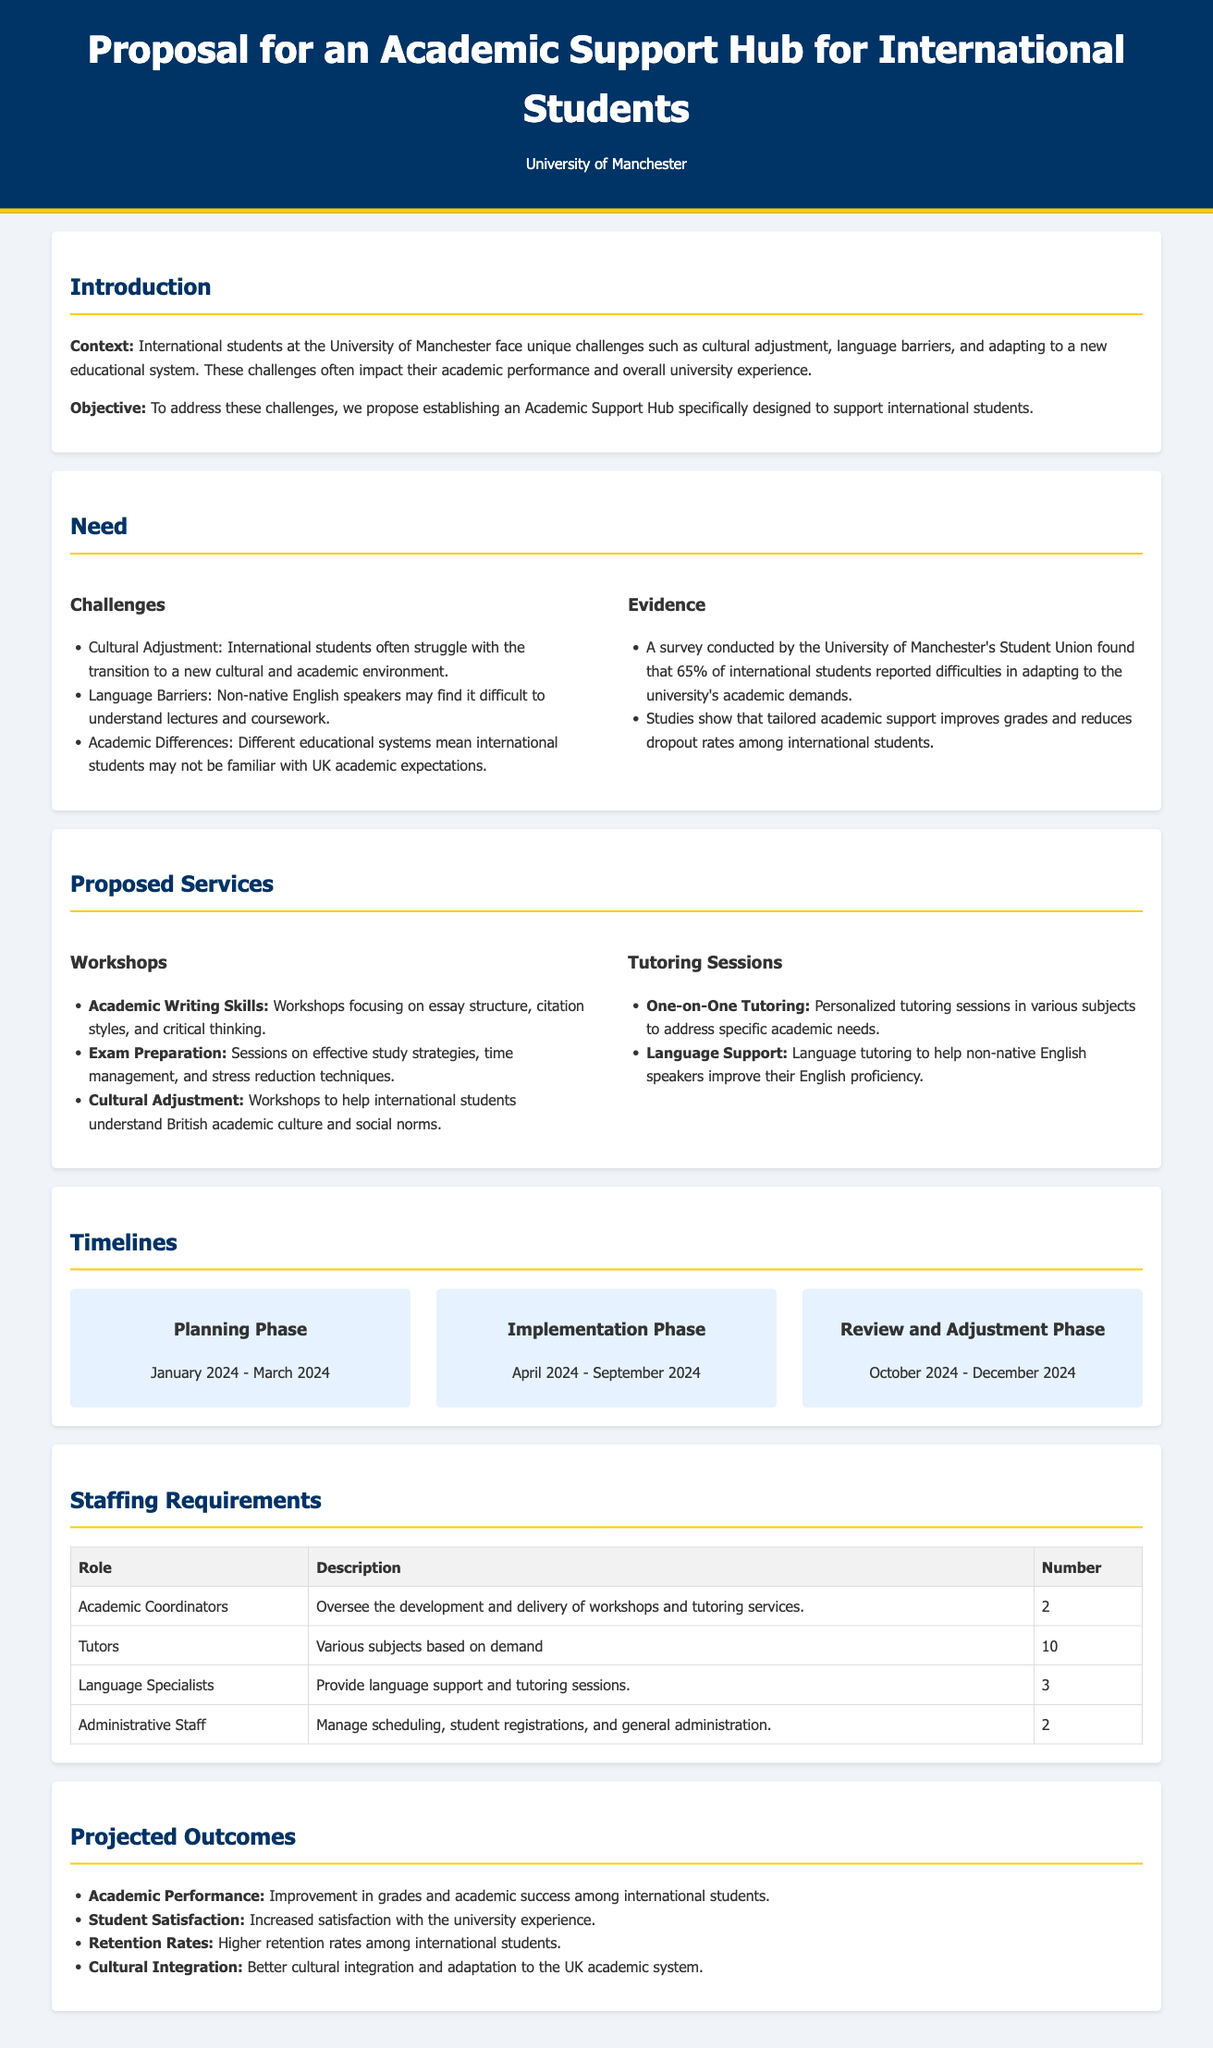What is the primary objective of the proposal? The proposal's objective is to establish an Academic Support Hub specifically designed to support international students.
Answer: To support international students How many language specialists are required? The staffing requirements section indicates that three language specialists are needed.
Answer: 3 What is the timeframe for the planning phase? The planning phase is scheduled from January 2024 to March 2024.
Answer: January 2024 - March 2024 What challenges do international students face according to the proposal? The proposal lists cultural adjustment, language barriers, and academic differences as challenges faced by international students.
Answer: Cultural adjustment, language barriers, academic differences What is one expected outcome of the proposed Academic Support Hub? One projected outcome is improvement in grades and academic success among international students.
Answer: Improvement in grades How many academic coordinators are proposed? The document specifies a need for two academic coordinators for the hub.
Answer: 2 What type of support will be provided in the workshops? Workshops will provide support in academic writing skills, exam preparation, and cultural adjustment.
Answer: Academic writing skills, exam preparation, cultural adjustment What are the implementation phase dates? The implementation phase is planned for April 2024 to September 2024.
Answer: April 2024 - September 2024 What is one of the reasons for creating the Academic Support Hub? The hub is being created to help international students adapt to a new educational system.
Answer: Adapt to a new educational system 